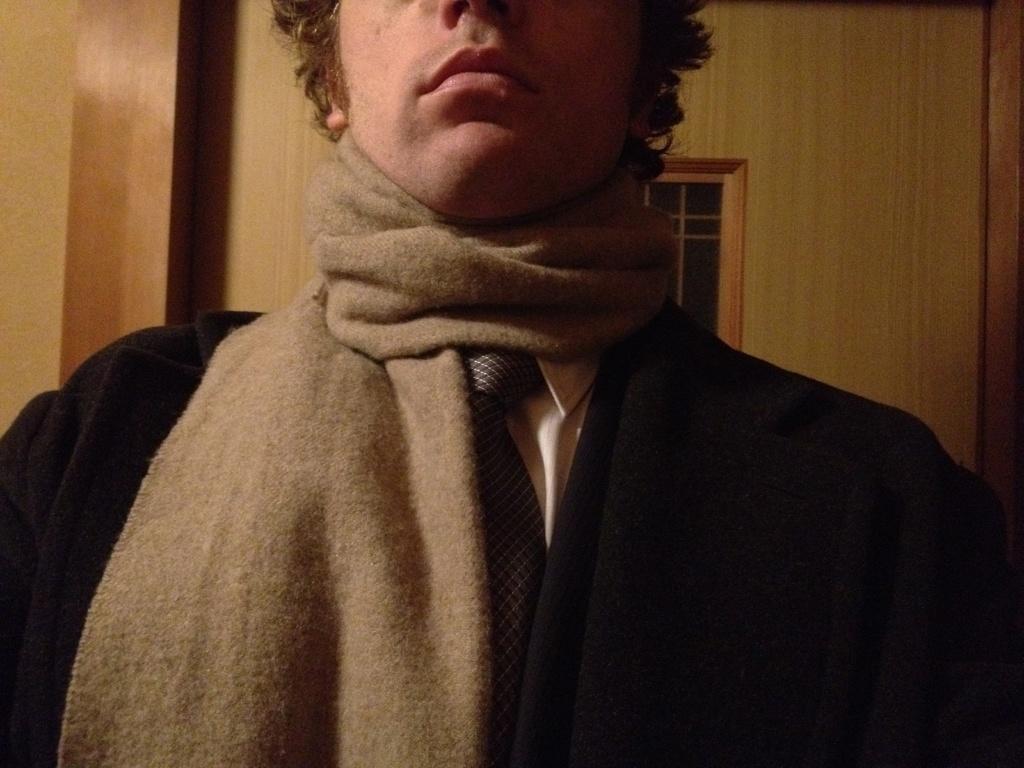In one or two sentences, can you explain what this image depicts? In the picture we can see a man standing, he is with a black color blazer and tie and in the background we can see a wooden wall with a window. 